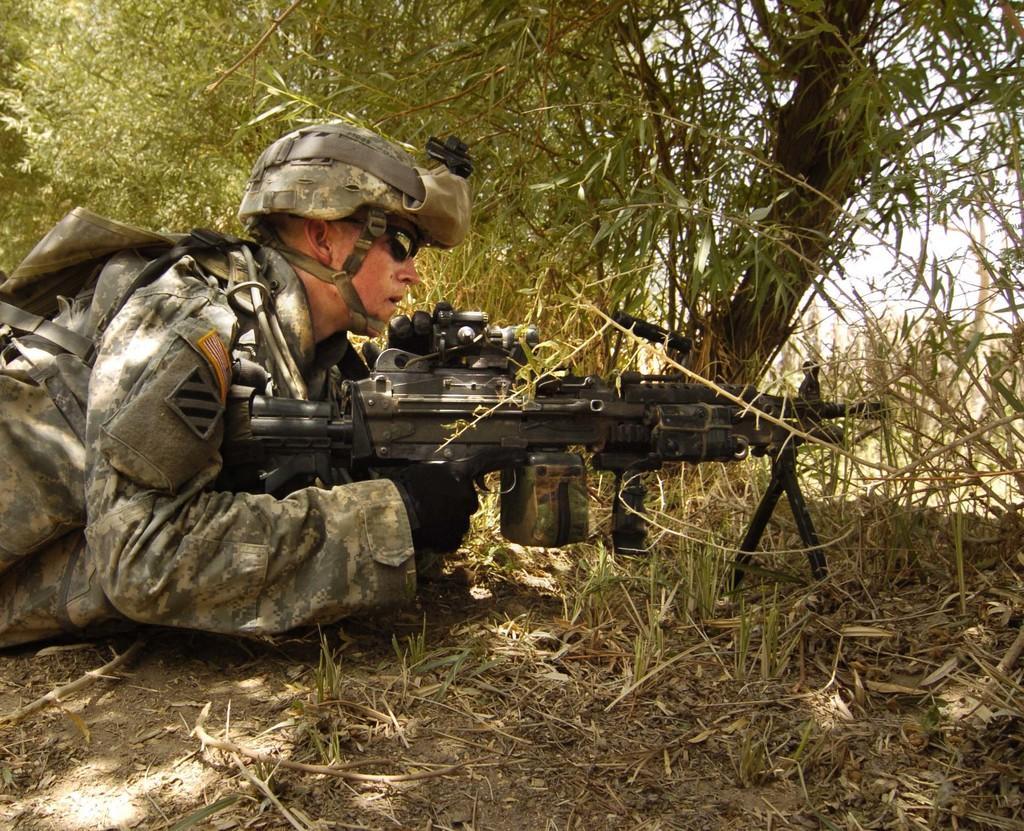In one or two sentences, can you explain what this image depicts? In this image I can see an army man is laying on the floor by holding the weapon. He wore an army dress, cap, there are trees in this image. 